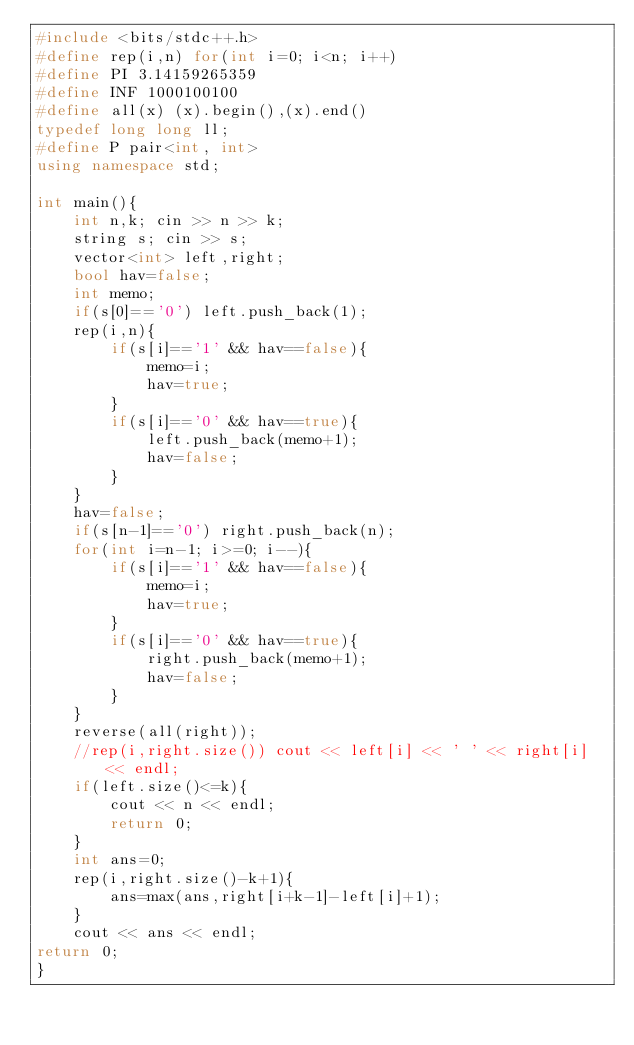Convert code to text. <code><loc_0><loc_0><loc_500><loc_500><_C++_>#include <bits/stdc++.h>
#define rep(i,n) for(int i=0; i<n; i++)
#define PI 3.14159265359
#define INF 1000100100
#define all(x) (x).begin(),(x).end()
typedef long long ll;
#define P pair<int, int>
using namespace std;

int main(){
    int n,k; cin >> n >> k;
    string s; cin >> s;
    vector<int> left,right;
    bool hav=false;
    int memo;
    if(s[0]=='0') left.push_back(1);
    rep(i,n){
        if(s[i]=='1' && hav==false){
            memo=i;
            hav=true;
        } 
        if(s[i]=='0' && hav==true){
            left.push_back(memo+1);
            hav=false;
        }
    }
    hav=false;
    if(s[n-1]=='0') right.push_back(n);
    for(int i=n-1; i>=0; i--){
        if(s[i]=='1' && hav==false){
            memo=i;
            hav=true;
        } 
        if(s[i]=='0' && hav==true){
            right.push_back(memo+1);
            hav=false;
        }
    }
    reverse(all(right));
    //rep(i,right.size()) cout << left[i] << ' ' << right[i] << endl;
    if(left.size()<=k){
        cout << n << endl;
        return 0;
    }
    int ans=0;
    rep(i,right.size()-k+1){
        ans=max(ans,right[i+k-1]-left[i]+1);
    }
    cout << ans << endl;
return 0;
}</code> 